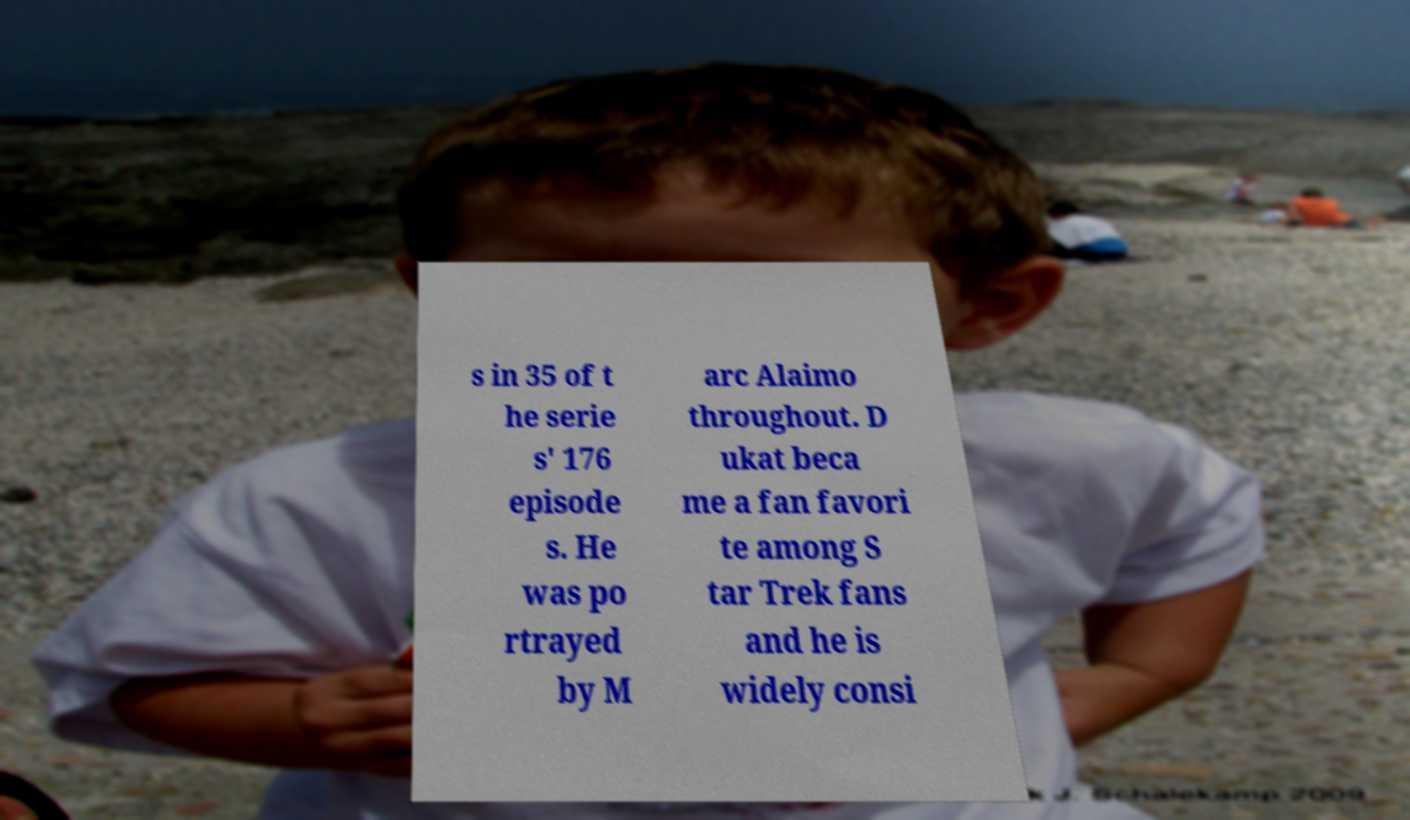I need the written content from this picture converted into text. Can you do that? s in 35 of t he serie s' 176 episode s. He was po rtrayed by M arc Alaimo throughout. D ukat beca me a fan favori te among S tar Trek fans and he is widely consi 